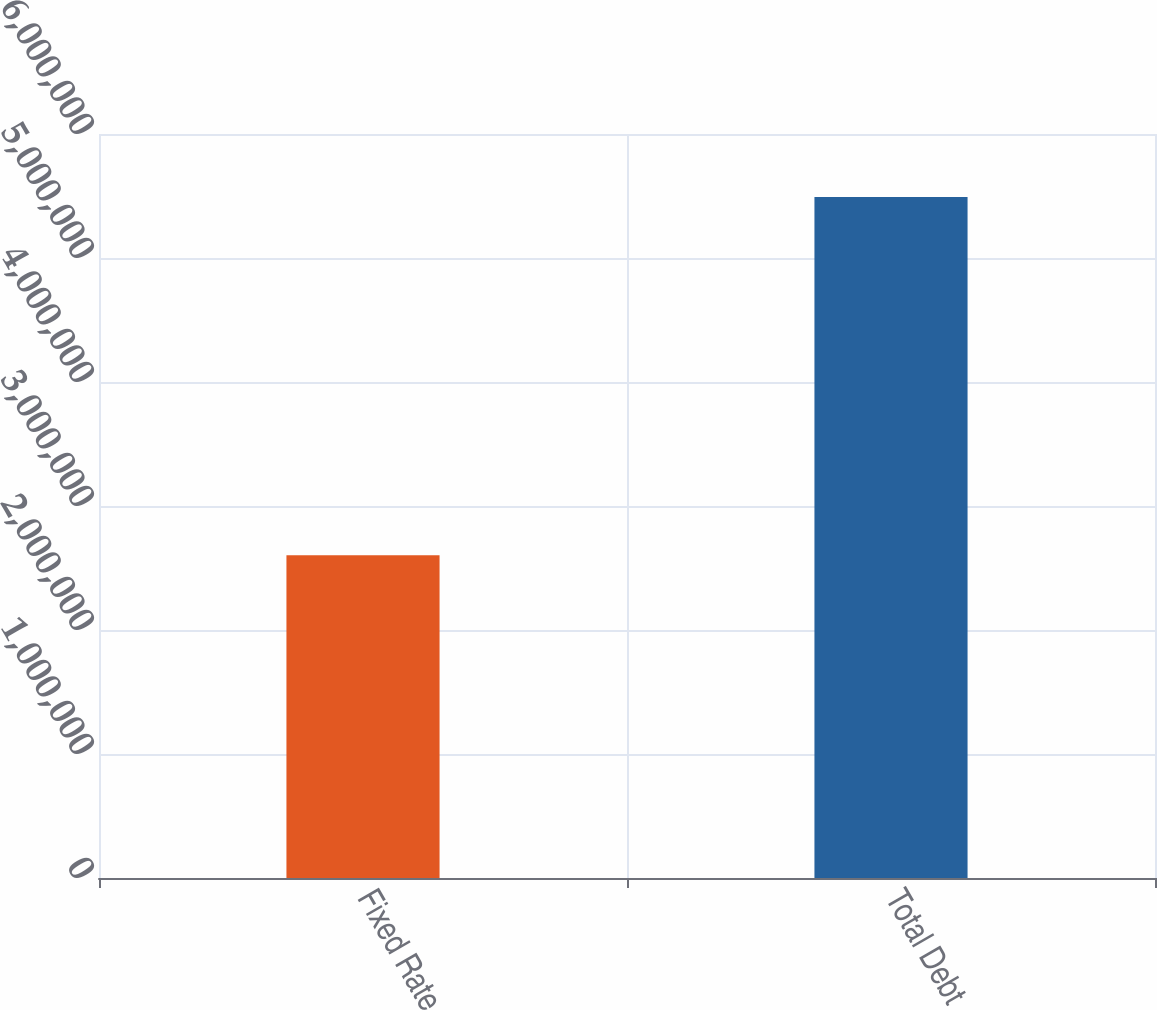Convert chart to OTSL. <chart><loc_0><loc_0><loc_500><loc_500><bar_chart><fcel>Fixed Rate<fcel>Total Debt<nl><fcel>2.6032e+06<fcel>5.49217e+06<nl></chart> 